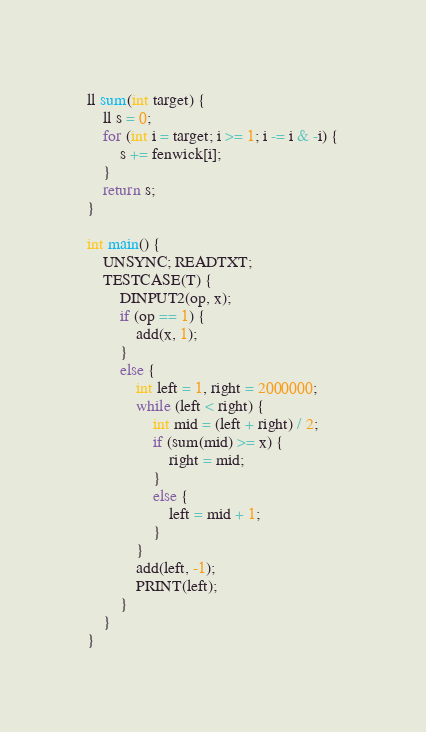Convert code to text. <code><loc_0><loc_0><loc_500><loc_500><_C++_>ll sum(int target) {
    ll s = 0;
    for (int i = target; i >= 1; i -= i & -i) {
        s += fenwick[i];
    }
    return s;
}

int main() {
    UNSYNC; READTXT;
    TESTCASE(T) {
        DINPUT2(op, x);
        if (op == 1) {
            add(x, 1);
        }
        else {
            int left = 1, right = 2000000;
            while (left < right) {
                int mid = (left + right) / 2;
                if (sum(mid) >= x) {
                    right = mid;
                }
                else {
                    left = mid + 1;
                }
            }
            add(left, -1);
            PRINT(left);
        }
    }
}</code> 